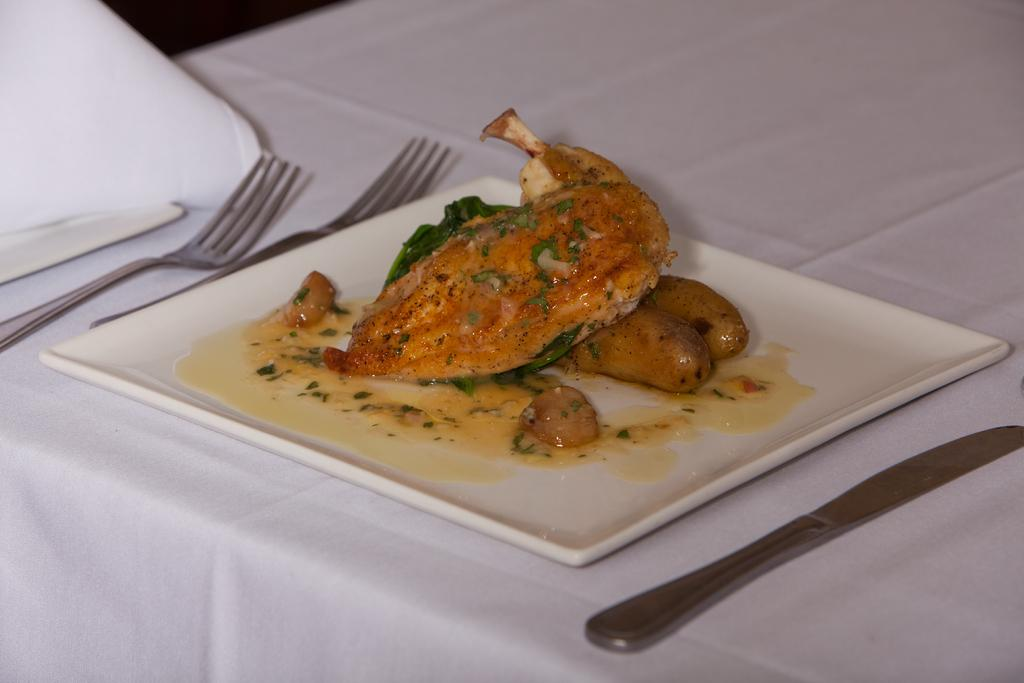What piece of furniture is present in the image? There is a table in the image. What is placed on the table? There is a plate on the table. What is on the plate? There is food in the plate, and there are spoons and a butter knife in the plate. What can be seen in the background of the image? There are objects visible in the background of the image. What plot are the sisters discussing in the image? There are no sisters or discussion present in the image. 